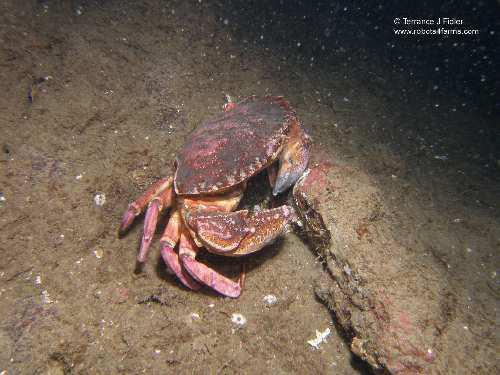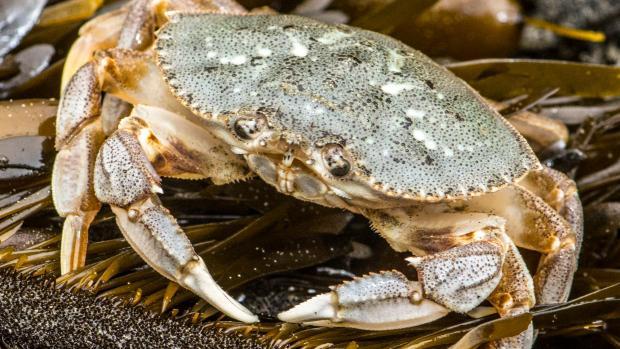The first image is the image on the left, the second image is the image on the right. Examine the images to the left and right. Is the description "In the image to the right, some of the crab's legs are red." accurate? Answer yes or no. No. The first image is the image on the left, the second image is the image on the right. For the images displayed, is the sentence "Each image shows an angled, forward-facing crab that is not held by a person, but the crab on the left is reddish-purple, and the crab on the right is not." factually correct? Answer yes or no. Yes. 